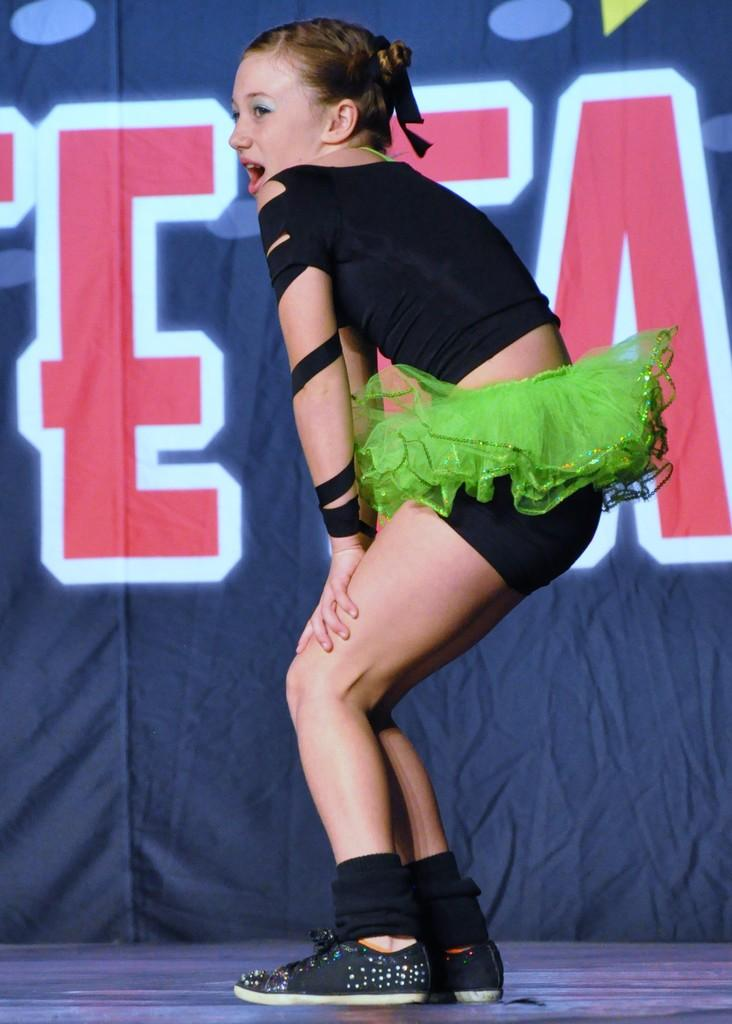Who is the main subject in the image? There is a girl in the center of the image. What can be seen in the background of the image? There is a cloth in the background of the image. What is visible at the bottom of the image? There is a floor visible at the bottom of the image. How many chairs are there in the image? There are no chairs present in the image. Is the girl taking a test in the image? There is no indication of a test in the image; it simply features a girl in the center. 